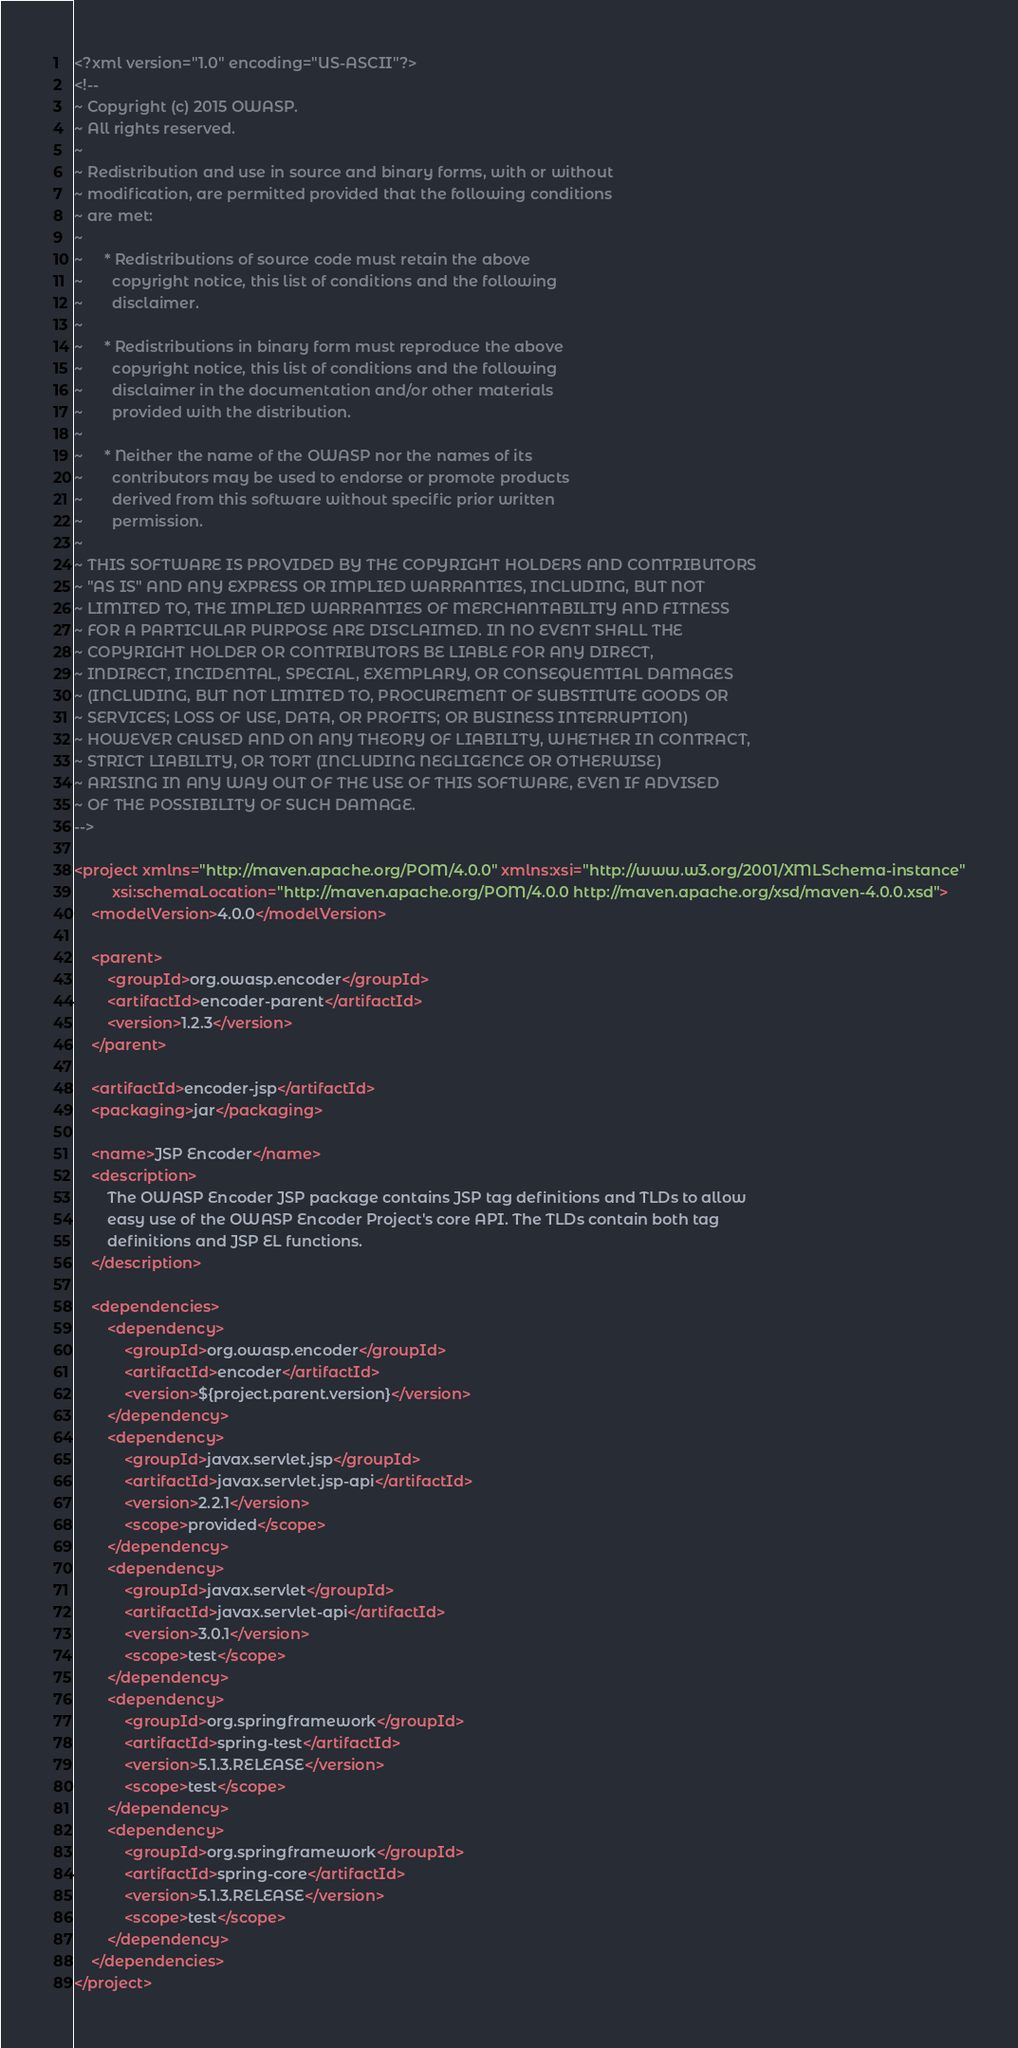Convert code to text. <code><loc_0><loc_0><loc_500><loc_500><_XML_><?xml version="1.0" encoding="US-ASCII"?>
<!--
~ Copyright (c) 2015 OWASP.
~ All rights reserved.
~
~ Redistribution and use in source and binary forms, with or without
~ modification, are permitted provided that the following conditions
~ are met:
~
~     * Redistributions of source code must retain the above
~       copyright notice, this list of conditions and the following
~       disclaimer.
~
~     * Redistributions in binary form must reproduce the above
~       copyright notice, this list of conditions and the following
~       disclaimer in the documentation and/or other materials
~       provided with the distribution.
~
~     * Neither the name of the OWASP nor the names of its
~       contributors may be used to endorse or promote products
~       derived from this software without specific prior written
~       permission.
~
~ THIS SOFTWARE IS PROVIDED BY THE COPYRIGHT HOLDERS AND CONTRIBUTORS
~ "AS IS" AND ANY EXPRESS OR IMPLIED WARRANTIES, INCLUDING, BUT NOT
~ LIMITED TO, THE IMPLIED WARRANTIES OF MERCHANTABILITY AND FITNESS
~ FOR A PARTICULAR PURPOSE ARE DISCLAIMED. IN NO EVENT SHALL THE
~ COPYRIGHT HOLDER OR CONTRIBUTORS BE LIABLE FOR ANY DIRECT,
~ INDIRECT, INCIDENTAL, SPECIAL, EXEMPLARY, OR CONSEQUENTIAL DAMAGES
~ (INCLUDING, BUT NOT LIMITED TO, PROCUREMENT OF SUBSTITUTE GOODS OR
~ SERVICES; LOSS OF USE, DATA, OR PROFITS; OR BUSINESS INTERRUPTION)
~ HOWEVER CAUSED AND ON ANY THEORY OF LIABILITY, WHETHER IN CONTRACT,
~ STRICT LIABILITY, OR TORT (INCLUDING NEGLIGENCE OR OTHERWISE)
~ ARISING IN ANY WAY OUT OF THE USE OF THIS SOFTWARE, EVEN IF ADVISED
~ OF THE POSSIBILITY OF SUCH DAMAGE.
-->

<project xmlns="http://maven.apache.org/POM/4.0.0" xmlns:xsi="http://www.w3.org/2001/XMLSchema-instance"
         xsi:schemaLocation="http://maven.apache.org/POM/4.0.0 http://maven.apache.org/xsd/maven-4.0.0.xsd">
    <modelVersion>4.0.0</modelVersion>

    <parent>
        <groupId>org.owasp.encoder</groupId>
        <artifactId>encoder-parent</artifactId>
        <version>1.2.3</version>
    </parent>

    <artifactId>encoder-jsp</artifactId>
    <packaging>jar</packaging>

    <name>JSP Encoder</name>
    <description>
        The OWASP Encoder JSP package contains JSP tag definitions and TLDs to allow
        easy use of the OWASP Encoder Project's core API. The TLDs contain both tag
        definitions and JSP EL functions.
    </description>

    <dependencies>
        <dependency>
            <groupId>org.owasp.encoder</groupId>
            <artifactId>encoder</artifactId>
            <version>${project.parent.version}</version>
        </dependency>
        <dependency>
            <groupId>javax.servlet.jsp</groupId>
            <artifactId>javax.servlet.jsp-api</artifactId>
            <version>2.2.1</version>
            <scope>provided</scope>
        </dependency>
        <dependency>
            <groupId>javax.servlet</groupId>
            <artifactId>javax.servlet-api</artifactId>
            <version>3.0.1</version>
            <scope>test</scope>
        </dependency>
        <dependency>
            <groupId>org.springframework</groupId>
            <artifactId>spring-test</artifactId>
            <version>5.1.3.RELEASE</version>
            <scope>test</scope>
        </dependency>
        <dependency>
            <groupId>org.springframework</groupId>
            <artifactId>spring-core</artifactId>
            <version>5.1.3.RELEASE</version>
            <scope>test</scope>
        </dependency>
    </dependencies>
</project>
</code> 